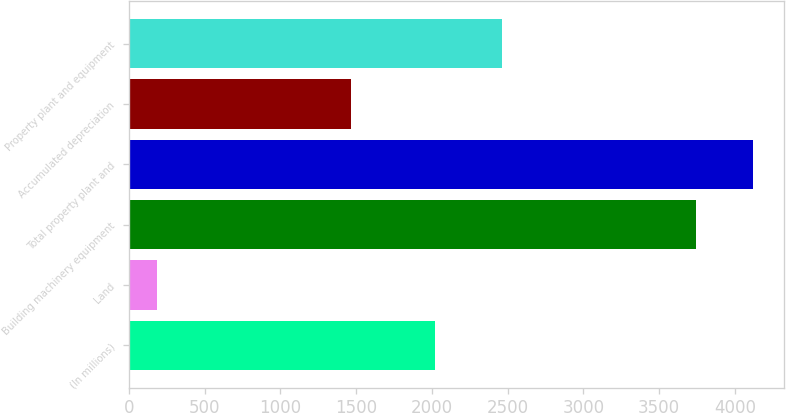Convert chart to OTSL. <chart><loc_0><loc_0><loc_500><loc_500><bar_chart><fcel>(In millions)<fcel>Land<fcel>Building machinery equipment<fcel>Total property plant and<fcel>Accumulated depreciation<fcel>Property plant and equipment<nl><fcel>2018<fcel>187<fcel>3746<fcel>4120.6<fcel>1469<fcel>2464<nl></chart> 